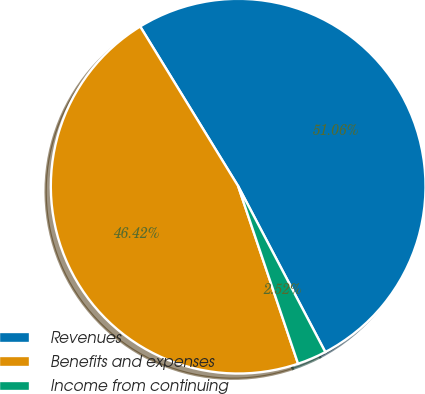Convert chart to OTSL. <chart><loc_0><loc_0><loc_500><loc_500><pie_chart><fcel>Revenues<fcel>Benefits and expenses<fcel>Income from continuing<nl><fcel>51.06%<fcel>46.42%<fcel>2.52%<nl></chart> 